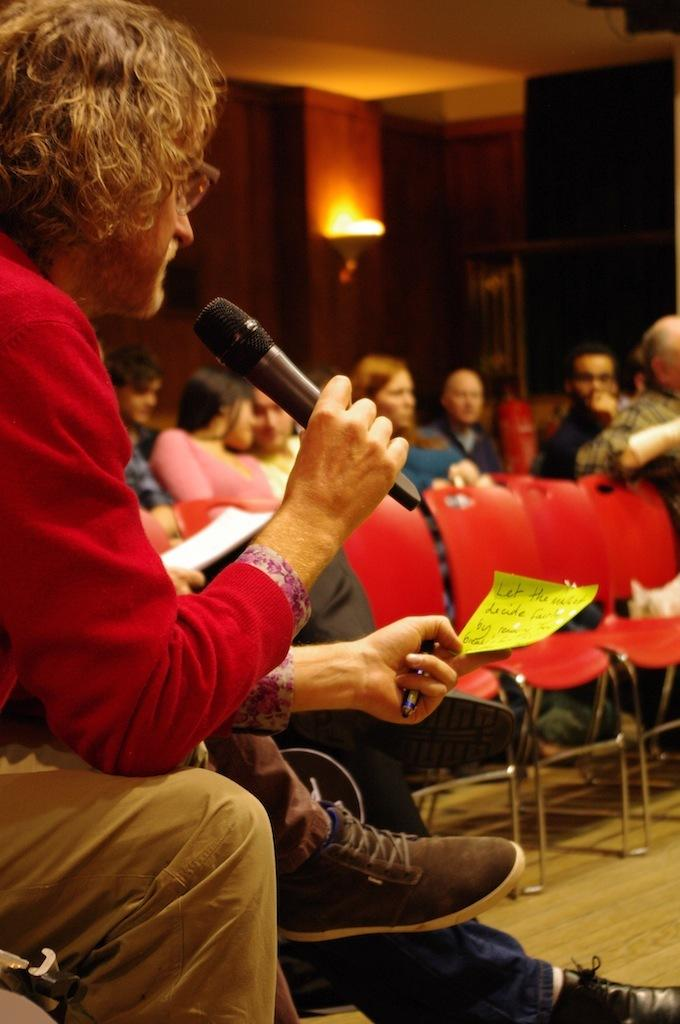What is the man in the image doing? The man is sitting in the image and holding a mic. What might the man be using the mic for? The man might be using the mic for speaking or singing. What can be seen in the background of the image? There are chairs in the background of the image, and people are sitting on them. What type of toothpaste is the man using in the image? There is no toothpaste present in the image; the man is holding a mic. What force is being applied by the man in the image? The provided facts do not mention any force being applied by the man; he is simply sitting and holding a mic. 